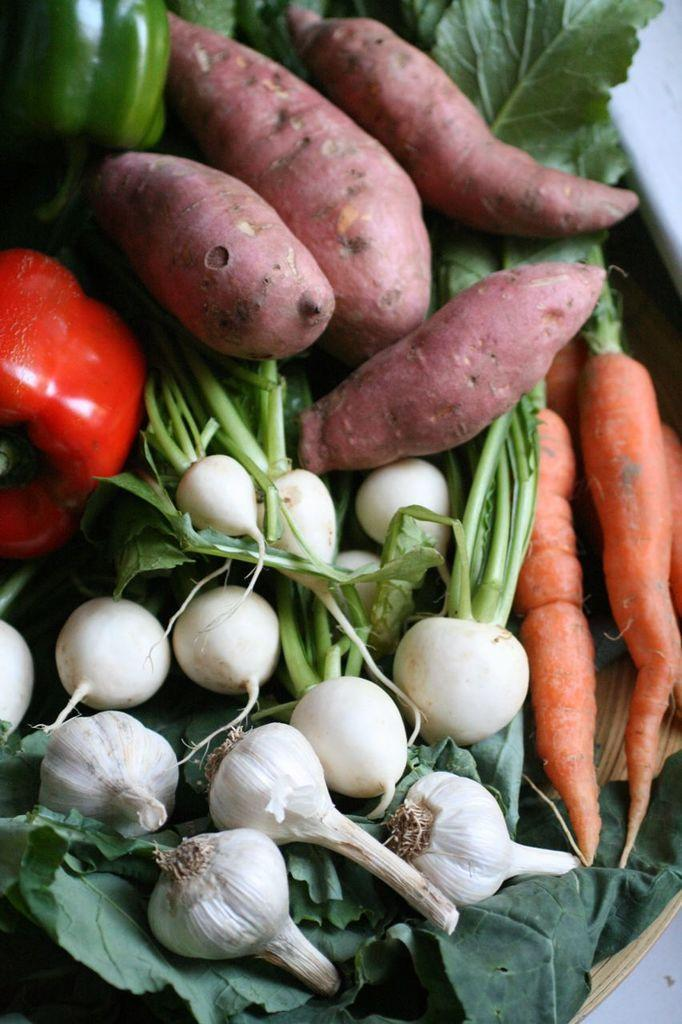What object is present in the image that can hold items? There is a basket in the image that can hold items. What type of food items can be seen inside the basket? Inside the basket, there are garlic, carrots, sweet potatoes, and bell peppers. Are there any other vegetables in the basket besides the ones mentioned? Yes, there are other vegetables in the basket. What type of lamp is hanging above the basket in the image? There is no lamp present in the image; it only features a basket with vegetables. Is there a chair next to the basket in the image? There is no chair present in the image; it only features a basket with vegetables. 